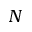<formula> <loc_0><loc_0><loc_500><loc_500>N</formula> 